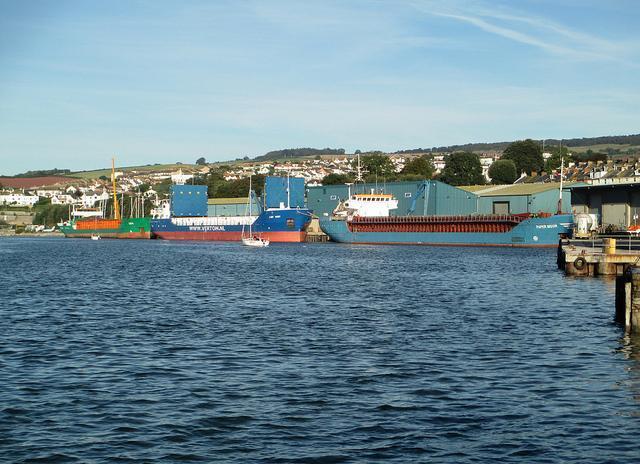How many boats are in the photo?
Give a very brief answer. 2. 